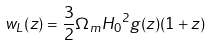Convert formula to latex. <formula><loc_0><loc_0><loc_500><loc_500>w _ { L } ( z ) = \frac { 3 } { 2 } \Omega _ { m } { H _ { 0 } } ^ { 2 } g ( z ) ( 1 + z )</formula> 